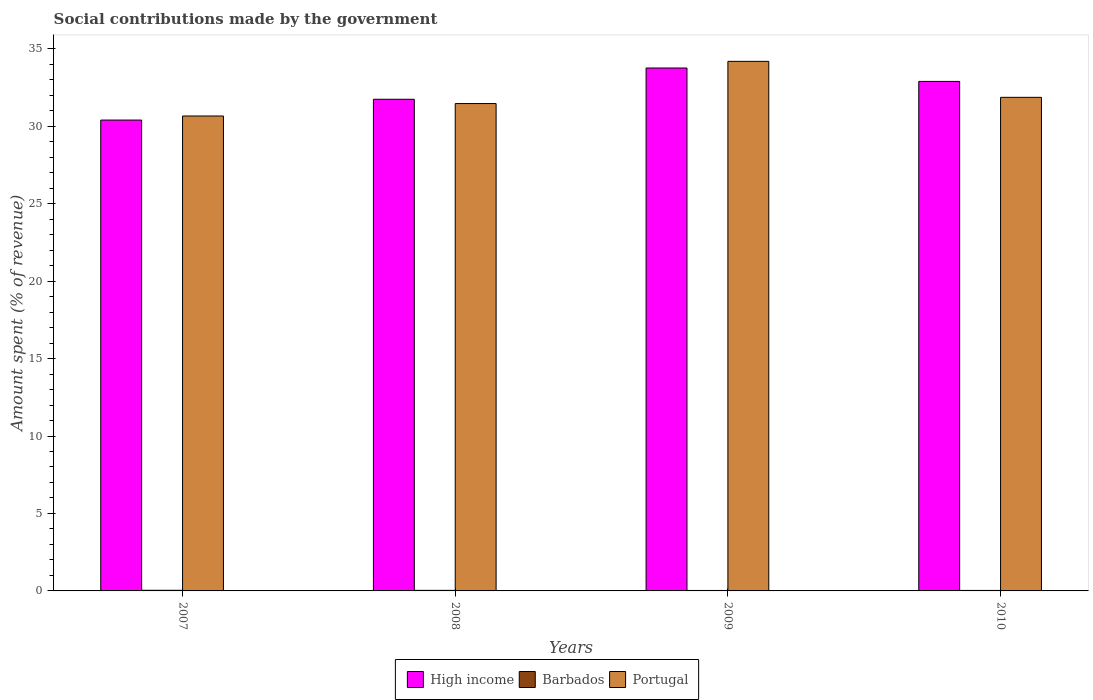How many groups of bars are there?
Keep it short and to the point. 4. Are the number of bars per tick equal to the number of legend labels?
Offer a terse response. Yes. Are the number of bars on each tick of the X-axis equal?
Provide a succinct answer. Yes. How many bars are there on the 3rd tick from the left?
Make the answer very short. 3. How many bars are there on the 1st tick from the right?
Ensure brevity in your answer.  3. What is the label of the 3rd group of bars from the left?
Provide a short and direct response. 2009. In how many cases, is the number of bars for a given year not equal to the number of legend labels?
Provide a short and direct response. 0. What is the amount spent (in %) on social contributions in Barbados in 2010?
Give a very brief answer. 0.03. Across all years, what is the maximum amount spent (in %) on social contributions in Barbados?
Your answer should be compact. 0.04. Across all years, what is the minimum amount spent (in %) on social contributions in Portugal?
Make the answer very short. 30.66. What is the total amount spent (in %) on social contributions in High income in the graph?
Your answer should be compact. 128.77. What is the difference between the amount spent (in %) on social contributions in Barbados in 2007 and that in 2010?
Ensure brevity in your answer.  0.01. What is the difference between the amount spent (in %) on social contributions in Portugal in 2008 and the amount spent (in %) on social contributions in High income in 2010?
Ensure brevity in your answer.  -1.43. What is the average amount spent (in %) on social contributions in Barbados per year?
Provide a short and direct response. 0.03. In the year 2008, what is the difference between the amount spent (in %) on social contributions in Barbados and amount spent (in %) on social contributions in High income?
Offer a terse response. -31.7. In how many years, is the amount spent (in %) on social contributions in Barbados greater than 27 %?
Provide a succinct answer. 0. What is the ratio of the amount spent (in %) on social contributions in High income in 2007 to that in 2010?
Provide a short and direct response. 0.92. Is the amount spent (in %) on social contributions in Portugal in 2007 less than that in 2010?
Offer a very short reply. Yes. Is the difference between the amount spent (in %) on social contributions in Barbados in 2007 and 2008 greater than the difference between the amount spent (in %) on social contributions in High income in 2007 and 2008?
Give a very brief answer. Yes. What is the difference between the highest and the second highest amount spent (in %) on social contributions in High income?
Offer a terse response. 0.87. What is the difference between the highest and the lowest amount spent (in %) on social contributions in High income?
Ensure brevity in your answer.  3.36. In how many years, is the amount spent (in %) on social contributions in High income greater than the average amount spent (in %) on social contributions in High income taken over all years?
Your response must be concise. 2. Is the sum of the amount spent (in %) on social contributions in High income in 2007 and 2010 greater than the maximum amount spent (in %) on social contributions in Barbados across all years?
Keep it short and to the point. Yes. What does the 1st bar from the right in 2008 represents?
Provide a succinct answer. Portugal. Is it the case that in every year, the sum of the amount spent (in %) on social contributions in Barbados and amount spent (in %) on social contributions in High income is greater than the amount spent (in %) on social contributions in Portugal?
Make the answer very short. No. Are all the bars in the graph horizontal?
Provide a succinct answer. No. Are the values on the major ticks of Y-axis written in scientific E-notation?
Provide a short and direct response. No. Does the graph contain any zero values?
Give a very brief answer. No. What is the title of the graph?
Keep it short and to the point. Social contributions made by the government. What is the label or title of the X-axis?
Your answer should be very brief. Years. What is the label or title of the Y-axis?
Ensure brevity in your answer.  Amount spent (% of revenue). What is the Amount spent (% of revenue) of High income in 2007?
Give a very brief answer. 30.39. What is the Amount spent (% of revenue) in Barbados in 2007?
Give a very brief answer. 0.04. What is the Amount spent (% of revenue) in Portugal in 2007?
Your answer should be compact. 30.66. What is the Amount spent (% of revenue) of High income in 2008?
Offer a very short reply. 31.73. What is the Amount spent (% of revenue) of Barbados in 2008?
Your answer should be very brief. 0.04. What is the Amount spent (% of revenue) in Portugal in 2008?
Give a very brief answer. 31.46. What is the Amount spent (% of revenue) of High income in 2009?
Your answer should be compact. 33.75. What is the Amount spent (% of revenue) of Barbados in 2009?
Ensure brevity in your answer.  0.03. What is the Amount spent (% of revenue) in Portugal in 2009?
Your answer should be compact. 34.18. What is the Amount spent (% of revenue) in High income in 2010?
Your answer should be compact. 32.89. What is the Amount spent (% of revenue) of Barbados in 2010?
Your answer should be very brief. 0.03. What is the Amount spent (% of revenue) of Portugal in 2010?
Ensure brevity in your answer.  31.86. Across all years, what is the maximum Amount spent (% of revenue) of High income?
Ensure brevity in your answer.  33.75. Across all years, what is the maximum Amount spent (% of revenue) of Barbados?
Ensure brevity in your answer.  0.04. Across all years, what is the maximum Amount spent (% of revenue) in Portugal?
Offer a terse response. 34.18. Across all years, what is the minimum Amount spent (% of revenue) of High income?
Keep it short and to the point. 30.39. Across all years, what is the minimum Amount spent (% of revenue) of Barbados?
Provide a short and direct response. 0.03. Across all years, what is the minimum Amount spent (% of revenue) of Portugal?
Make the answer very short. 30.66. What is the total Amount spent (% of revenue) in High income in the graph?
Give a very brief answer. 128.77. What is the total Amount spent (% of revenue) in Barbados in the graph?
Your answer should be compact. 0.14. What is the total Amount spent (% of revenue) in Portugal in the graph?
Your response must be concise. 128.16. What is the difference between the Amount spent (% of revenue) in High income in 2007 and that in 2008?
Offer a terse response. -1.34. What is the difference between the Amount spent (% of revenue) in Barbados in 2007 and that in 2008?
Provide a succinct answer. 0. What is the difference between the Amount spent (% of revenue) of Portugal in 2007 and that in 2008?
Make the answer very short. -0.8. What is the difference between the Amount spent (% of revenue) of High income in 2007 and that in 2009?
Your response must be concise. -3.36. What is the difference between the Amount spent (% of revenue) in Barbados in 2007 and that in 2009?
Your answer should be very brief. 0.01. What is the difference between the Amount spent (% of revenue) in Portugal in 2007 and that in 2009?
Provide a succinct answer. -3.53. What is the difference between the Amount spent (% of revenue) in High income in 2007 and that in 2010?
Give a very brief answer. -2.49. What is the difference between the Amount spent (% of revenue) in Barbados in 2007 and that in 2010?
Ensure brevity in your answer.  0.01. What is the difference between the Amount spent (% of revenue) in Portugal in 2007 and that in 2010?
Offer a terse response. -1.2. What is the difference between the Amount spent (% of revenue) of High income in 2008 and that in 2009?
Give a very brief answer. -2.02. What is the difference between the Amount spent (% of revenue) of Barbados in 2008 and that in 2009?
Provide a short and direct response. 0.01. What is the difference between the Amount spent (% of revenue) in Portugal in 2008 and that in 2009?
Provide a succinct answer. -2.72. What is the difference between the Amount spent (% of revenue) in High income in 2008 and that in 2010?
Provide a succinct answer. -1.15. What is the difference between the Amount spent (% of revenue) in Barbados in 2008 and that in 2010?
Provide a short and direct response. 0. What is the difference between the Amount spent (% of revenue) of Portugal in 2008 and that in 2010?
Make the answer very short. -0.4. What is the difference between the Amount spent (% of revenue) in High income in 2009 and that in 2010?
Provide a short and direct response. 0.87. What is the difference between the Amount spent (% of revenue) of Barbados in 2009 and that in 2010?
Provide a short and direct response. -0. What is the difference between the Amount spent (% of revenue) of Portugal in 2009 and that in 2010?
Offer a very short reply. 2.32. What is the difference between the Amount spent (% of revenue) of High income in 2007 and the Amount spent (% of revenue) of Barbados in 2008?
Your answer should be very brief. 30.36. What is the difference between the Amount spent (% of revenue) in High income in 2007 and the Amount spent (% of revenue) in Portugal in 2008?
Offer a terse response. -1.07. What is the difference between the Amount spent (% of revenue) of Barbados in 2007 and the Amount spent (% of revenue) of Portugal in 2008?
Give a very brief answer. -31.42. What is the difference between the Amount spent (% of revenue) in High income in 2007 and the Amount spent (% of revenue) in Barbados in 2009?
Offer a very short reply. 30.36. What is the difference between the Amount spent (% of revenue) of High income in 2007 and the Amount spent (% of revenue) of Portugal in 2009?
Ensure brevity in your answer.  -3.79. What is the difference between the Amount spent (% of revenue) in Barbados in 2007 and the Amount spent (% of revenue) in Portugal in 2009?
Your answer should be compact. -34.14. What is the difference between the Amount spent (% of revenue) of High income in 2007 and the Amount spent (% of revenue) of Barbados in 2010?
Keep it short and to the point. 30.36. What is the difference between the Amount spent (% of revenue) in High income in 2007 and the Amount spent (% of revenue) in Portugal in 2010?
Make the answer very short. -1.47. What is the difference between the Amount spent (% of revenue) in Barbados in 2007 and the Amount spent (% of revenue) in Portugal in 2010?
Ensure brevity in your answer.  -31.82. What is the difference between the Amount spent (% of revenue) in High income in 2008 and the Amount spent (% of revenue) in Barbados in 2009?
Keep it short and to the point. 31.71. What is the difference between the Amount spent (% of revenue) of High income in 2008 and the Amount spent (% of revenue) of Portugal in 2009?
Provide a succinct answer. -2.45. What is the difference between the Amount spent (% of revenue) of Barbados in 2008 and the Amount spent (% of revenue) of Portugal in 2009?
Make the answer very short. -34.15. What is the difference between the Amount spent (% of revenue) of High income in 2008 and the Amount spent (% of revenue) of Barbados in 2010?
Provide a short and direct response. 31.7. What is the difference between the Amount spent (% of revenue) in High income in 2008 and the Amount spent (% of revenue) in Portugal in 2010?
Your answer should be very brief. -0.13. What is the difference between the Amount spent (% of revenue) of Barbados in 2008 and the Amount spent (% of revenue) of Portugal in 2010?
Keep it short and to the point. -31.82. What is the difference between the Amount spent (% of revenue) of High income in 2009 and the Amount spent (% of revenue) of Barbados in 2010?
Ensure brevity in your answer.  33.72. What is the difference between the Amount spent (% of revenue) of High income in 2009 and the Amount spent (% of revenue) of Portugal in 2010?
Offer a terse response. 1.89. What is the difference between the Amount spent (% of revenue) in Barbados in 2009 and the Amount spent (% of revenue) in Portugal in 2010?
Your answer should be compact. -31.83. What is the average Amount spent (% of revenue) of High income per year?
Your answer should be very brief. 32.19. What is the average Amount spent (% of revenue) in Barbados per year?
Provide a succinct answer. 0.03. What is the average Amount spent (% of revenue) of Portugal per year?
Provide a short and direct response. 32.04. In the year 2007, what is the difference between the Amount spent (% of revenue) in High income and Amount spent (% of revenue) in Barbados?
Ensure brevity in your answer.  30.35. In the year 2007, what is the difference between the Amount spent (% of revenue) of High income and Amount spent (% of revenue) of Portugal?
Your response must be concise. -0.26. In the year 2007, what is the difference between the Amount spent (% of revenue) of Barbados and Amount spent (% of revenue) of Portugal?
Provide a short and direct response. -30.62. In the year 2008, what is the difference between the Amount spent (% of revenue) in High income and Amount spent (% of revenue) in Barbados?
Your answer should be compact. 31.7. In the year 2008, what is the difference between the Amount spent (% of revenue) in High income and Amount spent (% of revenue) in Portugal?
Provide a succinct answer. 0.28. In the year 2008, what is the difference between the Amount spent (% of revenue) of Barbados and Amount spent (% of revenue) of Portugal?
Your response must be concise. -31.42. In the year 2009, what is the difference between the Amount spent (% of revenue) in High income and Amount spent (% of revenue) in Barbados?
Give a very brief answer. 33.72. In the year 2009, what is the difference between the Amount spent (% of revenue) of High income and Amount spent (% of revenue) of Portugal?
Keep it short and to the point. -0.43. In the year 2009, what is the difference between the Amount spent (% of revenue) in Barbados and Amount spent (% of revenue) in Portugal?
Offer a very short reply. -34.15. In the year 2010, what is the difference between the Amount spent (% of revenue) in High income and Amount spent (% of revenue) in Barbados?
Ensure brevity in your answer.  32.86. In the year 2010, what is the difference between the Amount spent (% of revenue) in High income and Amount spent (% of revenue) in Portugal?
Offer a terse response. 1.03. In the year 2010, what is the difference between the Amount spent (% of revenue) of Barbados and Amount spent (% of revenue) of Portugal?
Keep it short and to the point. -31.83. What is the ratio of the Amount spent (% of revenue) in High income in 2007 to that in 2008?
Offer a very short reply. 0.96. What is the ratio of the Amount spent (% of revenue) of Barbados in 2007 to that in 2008?
Offer a very short reply. 1.12. What is the ratio of the Amount spent (% of revenue) in Portugal in 2007 to that in 2008?
Your answer should be compact. 0.97. What is the ratio of the Amount spent (% of revenue) of High income in 2007 to that in 2009?
Your answer should be compact. 0.9. What is the ratio of the Amount spent (% of revenue) of Barbados in 2007 to that in 2009?
Make the answer very short. 1.35. What is the ratio of the Amount spent (% of revenue) in Portugal in 2007 to that in 2009?
Provide a succinct answer. 0.9. What is the ratio of the Amount spent (% of revenue) of High income in 2007 to that in 2010?
Your answer should be compact. 0.92. What is the ratio of the Amount spent (% of revenue) in Barbados in 2007 to that in 2010?
Keep it short and to the point. 1.25. What is the ratio of the Amount spent (% of revenue) in Portugal in 2007 to that in 2010?
Offer a very short reply. 0.96. What is the ratio of the Amount spent (% of revenue) of High income in 2008 to that in 2009?
Provide a short and direct response. 0.94. What is the ratio of the Amount spent (% of revenue) of Barbados in 2008 to that in 2009?
Provide a succinct answer. 1.21. What is the ratio of the Amount spent (% of revenue) of Portugal in 2008 to that in 2009?
Provide a short and direct response. 0.92. What is the ratio of the Amount spent (% of revenue) of High income in 2008 to that in 2010?
Offer a terse response. 0.96. What is the ratio of the Amount spent (% of revenue) in Barbados in 2008 to that in 2010?
Offer a terse response. 1.12. What is the ratio of the Amount spent (% of revenue) in Portugal in 2008 to that in 2010?
Offer a very short reply. 0.99. What is the ratio of the Amount spent (% of revenue) of High income in 2009 to that in 2010?
Your answer should be compact. 1.03. What is the ratio of the Amount spent (% of revenue) in Barbados in 2009 to that in 2010?
Your answer should be very brief. 0.92. What is the ratio of the Amount spent (% of revenue) of Portugal in 2009 to that in 2010?
Keep it short and to the point. 1.07. What is the difference between the highest and the second highest Amount spent (% of revenue) of High income?
Provide a short and direct response. 0.87. What is the difference between the highest and the second highest Amount spent (% of revenue) in Barbados?
Make the answer very short. 0. What is the difference between the highest and the second highest Amount spent (% of revenue) in Portugal?
Give a very brief answer. 2.32. What is the difference between the highest and the lowest Amount spent (% of revenue) in High income?
Offer a terse response. 3.36. What is the difference between the highest and the lowest Amount spent (% of revenue) in Barbados?
Ensure brevity in your answer.  0.01. What is the difference between the highest and the lowest Amount spent (% of revenue) of Portugal?
Make the answer very short. 3.53. 